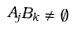<formula> <loc_0><loc_0><loc_500><loc_500>A _ { j } B _ { k } \ne \emptyset</formula> 